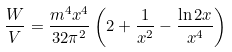Convert formula to latex. <formula><loc_0><loc_0><loc_500><loc_500>\frac { W } { V } = \frac { m ^ { 4 } x ^ { 4 } } { 3 2 \pi ^ { 2 } } \left ( 2 + \frac { 1 } { x ^ { 2 } } - \frac { \ln 2 x } { x ^ { 4 } } \right )</formula> 